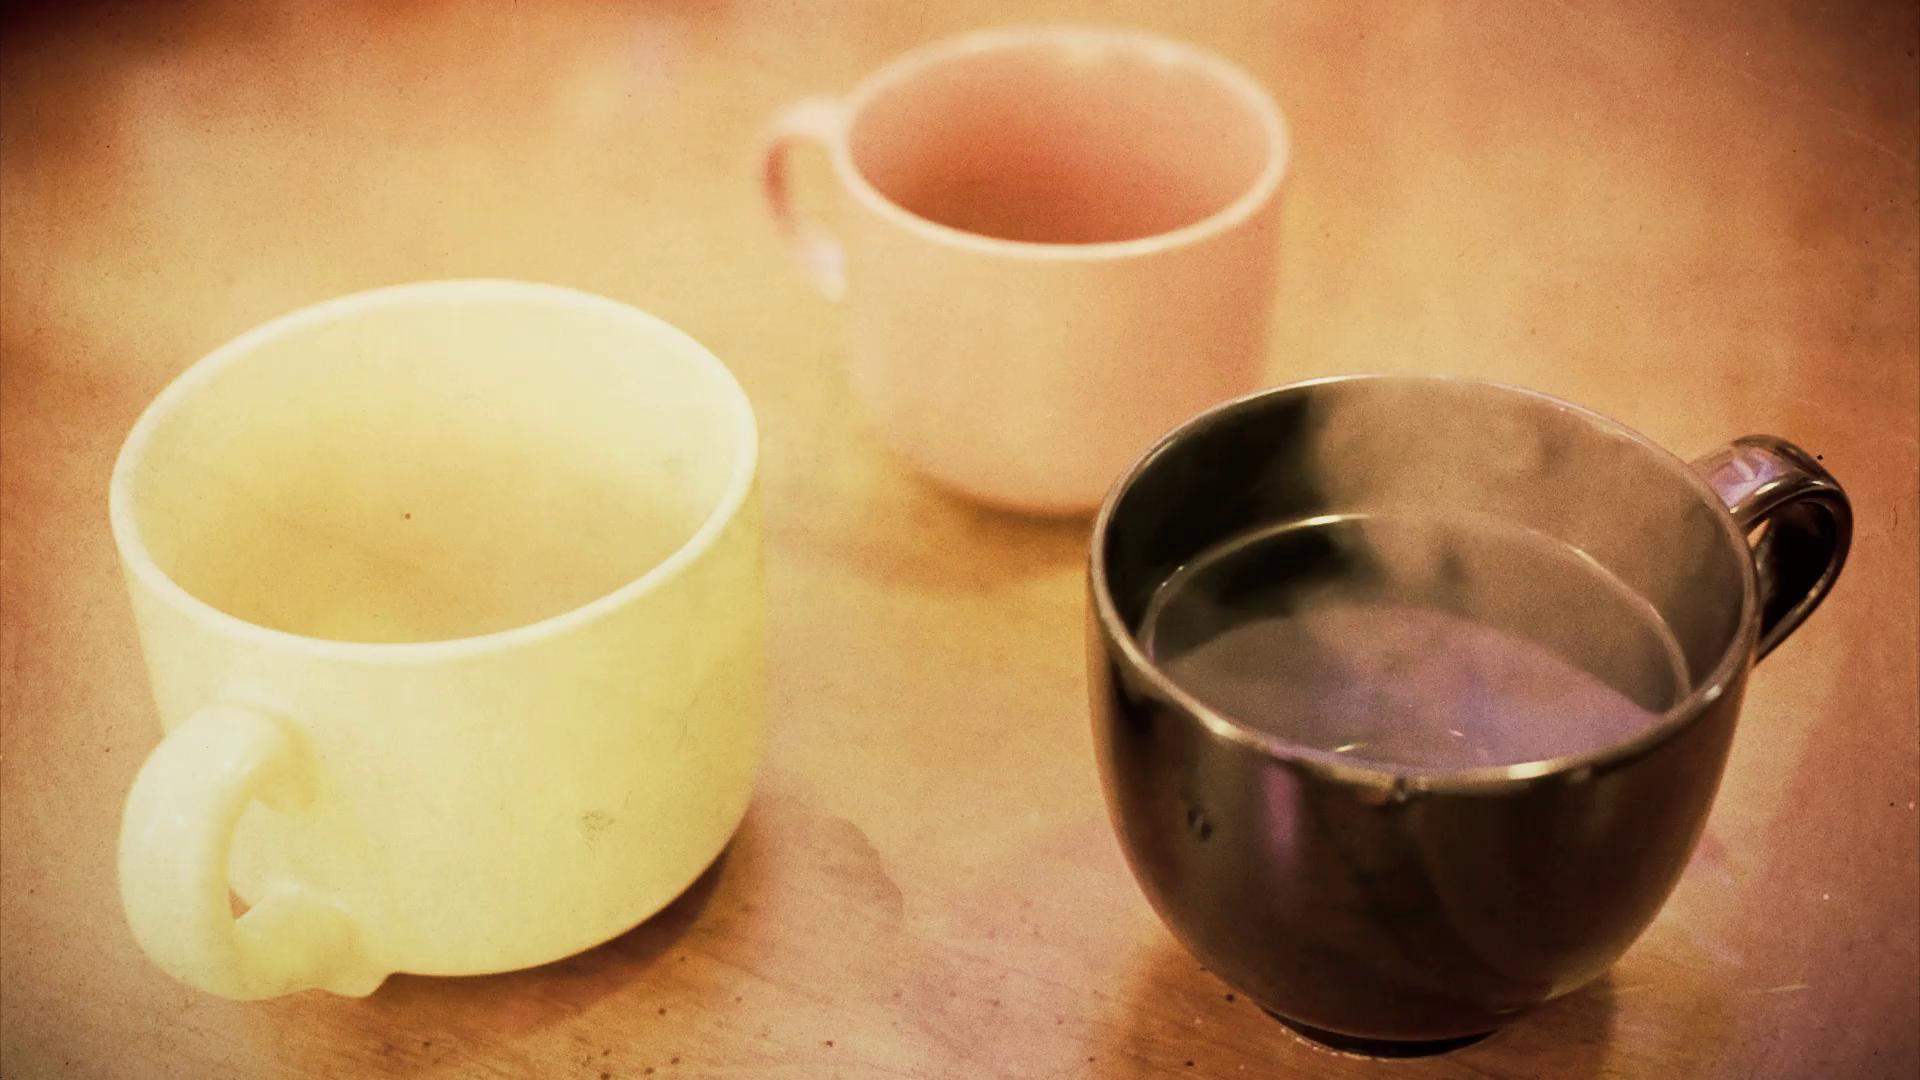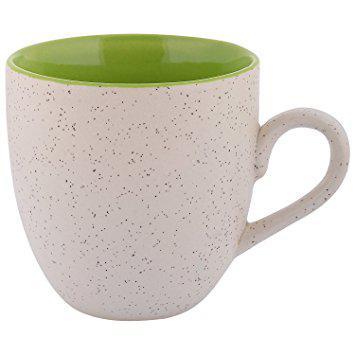The first image is the image on the left, the second image is the image on the right. For the images shown, is this caption "Exactly four different cups with matching saucers are shown, three in one image and one in a second image." true? Answer yes or no. No. The first image is the image on the left, the second image is the image on the right. Analyze the images presented: Is the assertion "An image shows a trio of gold-trimmed cup and saucer sets, including one that is robin's egg blue." valid? Answer yes or no. No. 